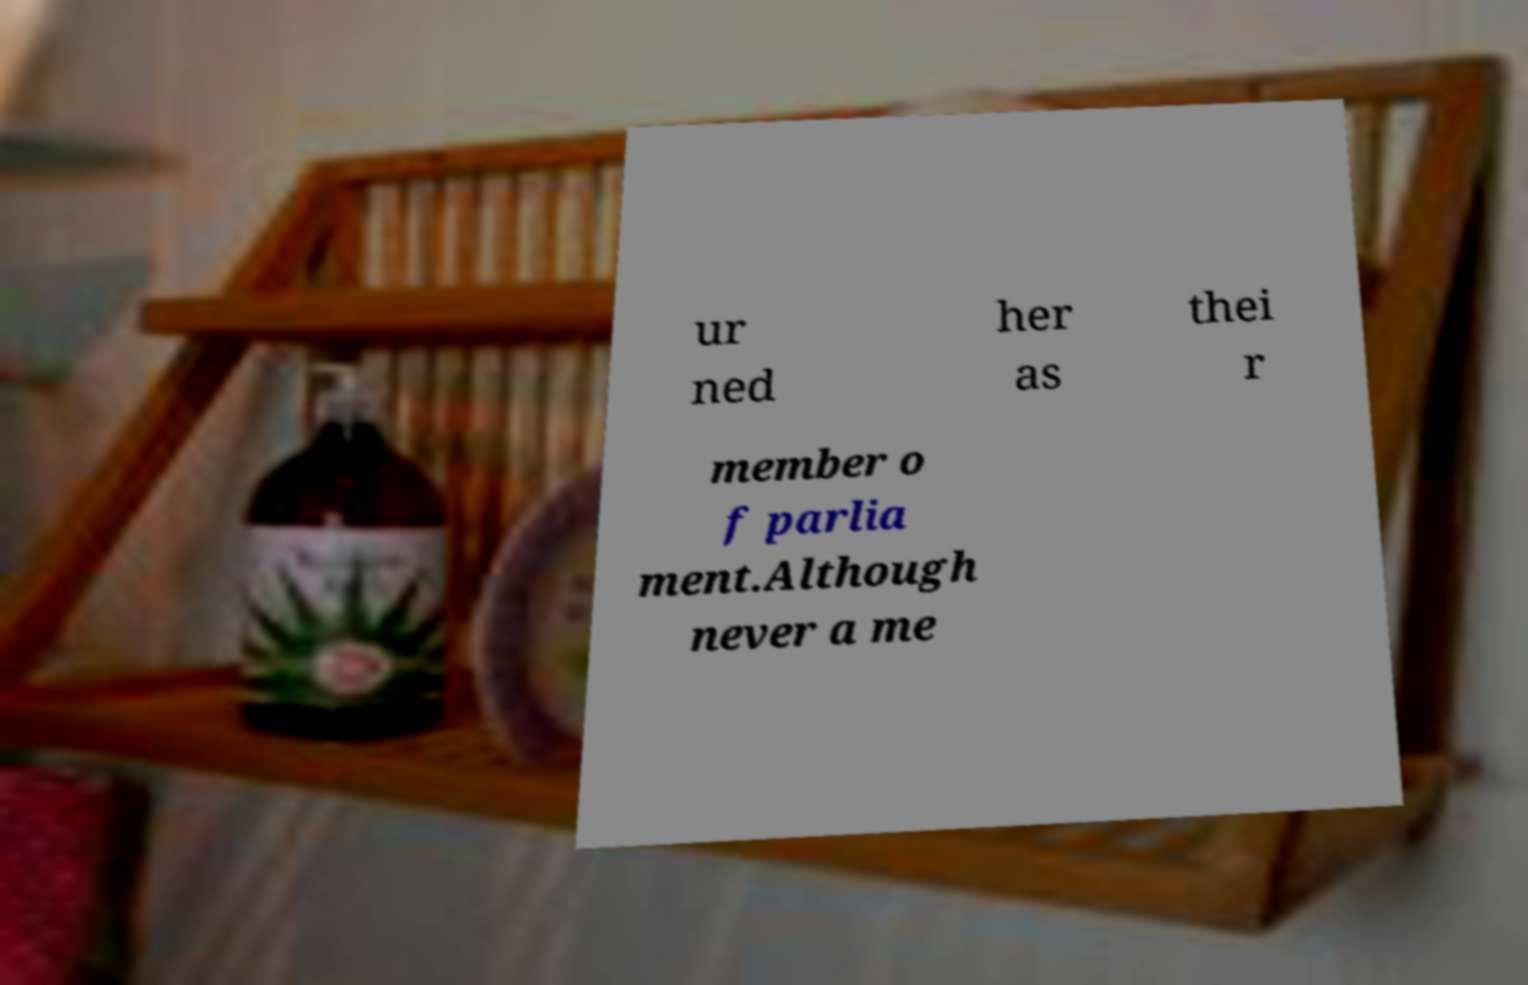Can you read and provide the text displayed in the image?This photo seems to have some interesting text. Can you extract and type it out for me? ur ned her as thei r member o f parlia ment.Although never a me 